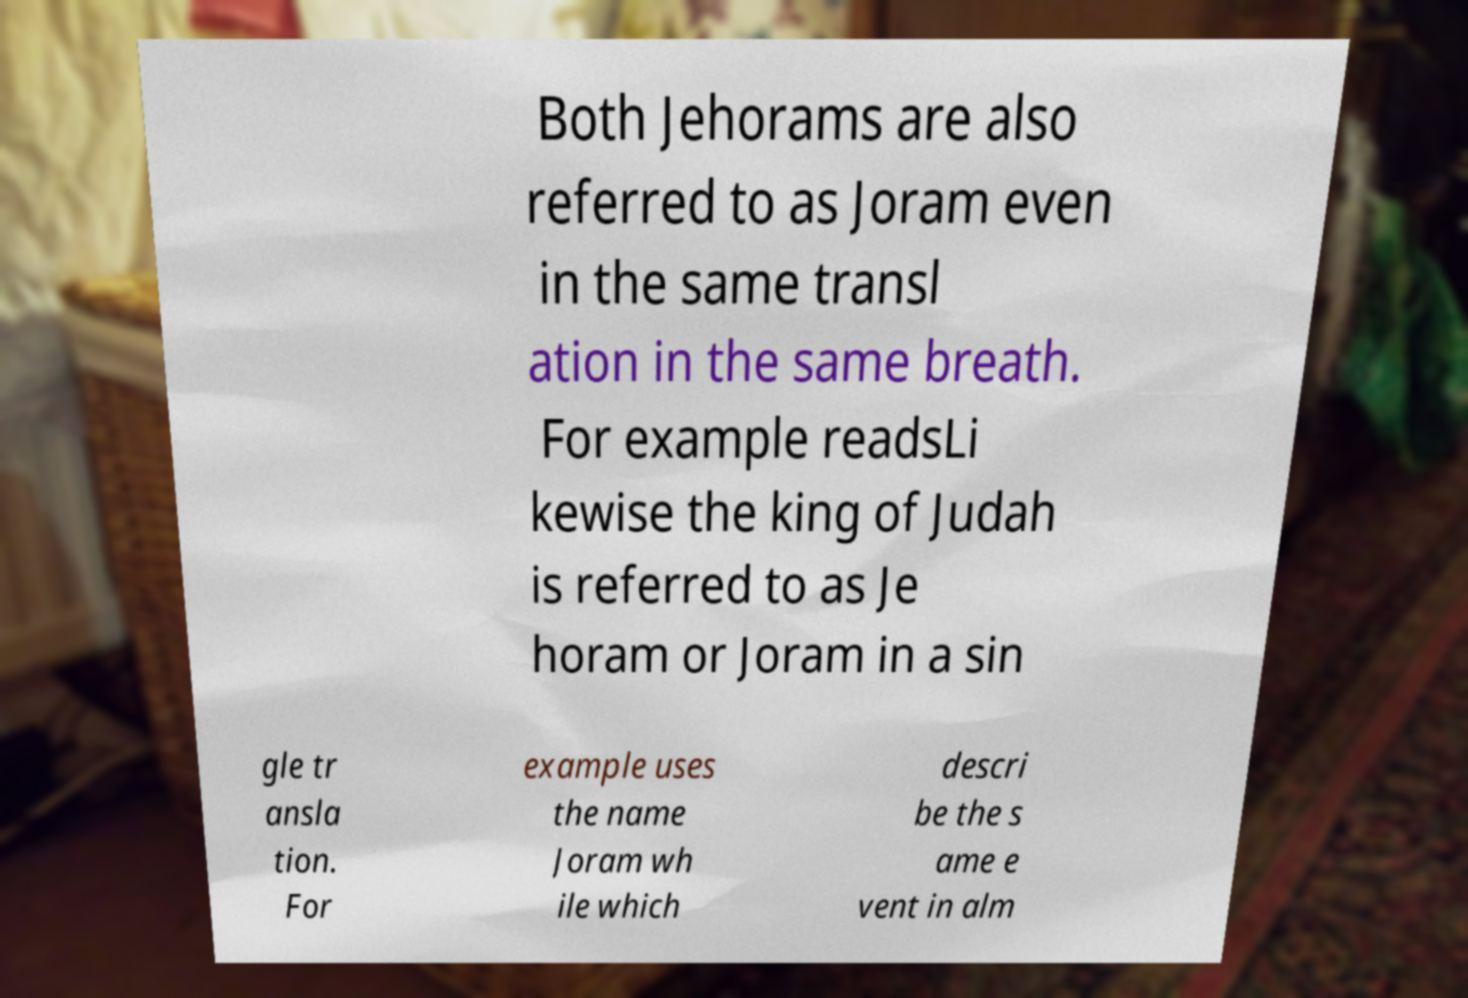I need the written content from this picture converted into text. Can you do that? Both Jehorams are also referred to as Joram even in the same transl ation in the same breath. For example readsLi kewise the king of Judah is referred to as Je horam or Joram in a sin gle tr ansla tion. For example uses the name Joram wh ile which descri be the s ame e vent in alm 